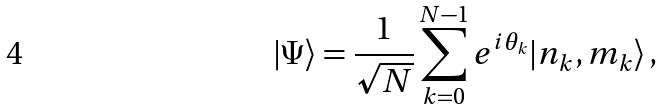Convert formula to latex. <formula><loc_0><loc_0><loc_500><loc_500>| \Psi \rangle = \frac { 1 } { \sqrt { N } } \sum _ { k = 0 } ^ { N - 1 } e ^ { i \theta _ { k } } | n _ { k } , m _ { k } \rangle \, ,</formula> 